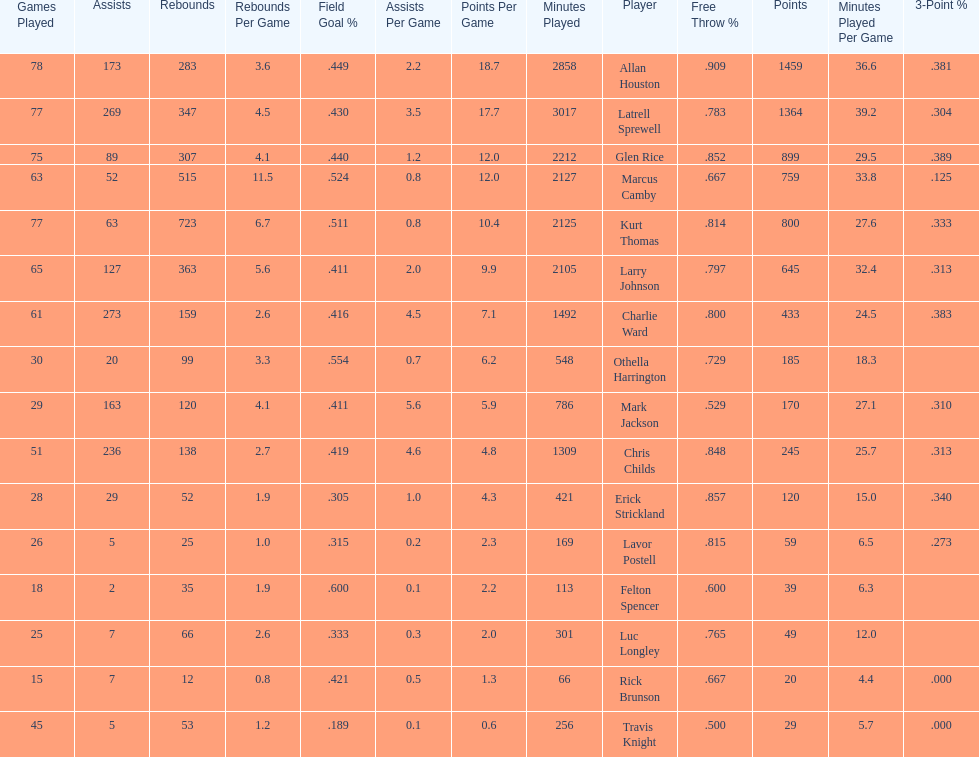How many games did larry johnson play? 65. 